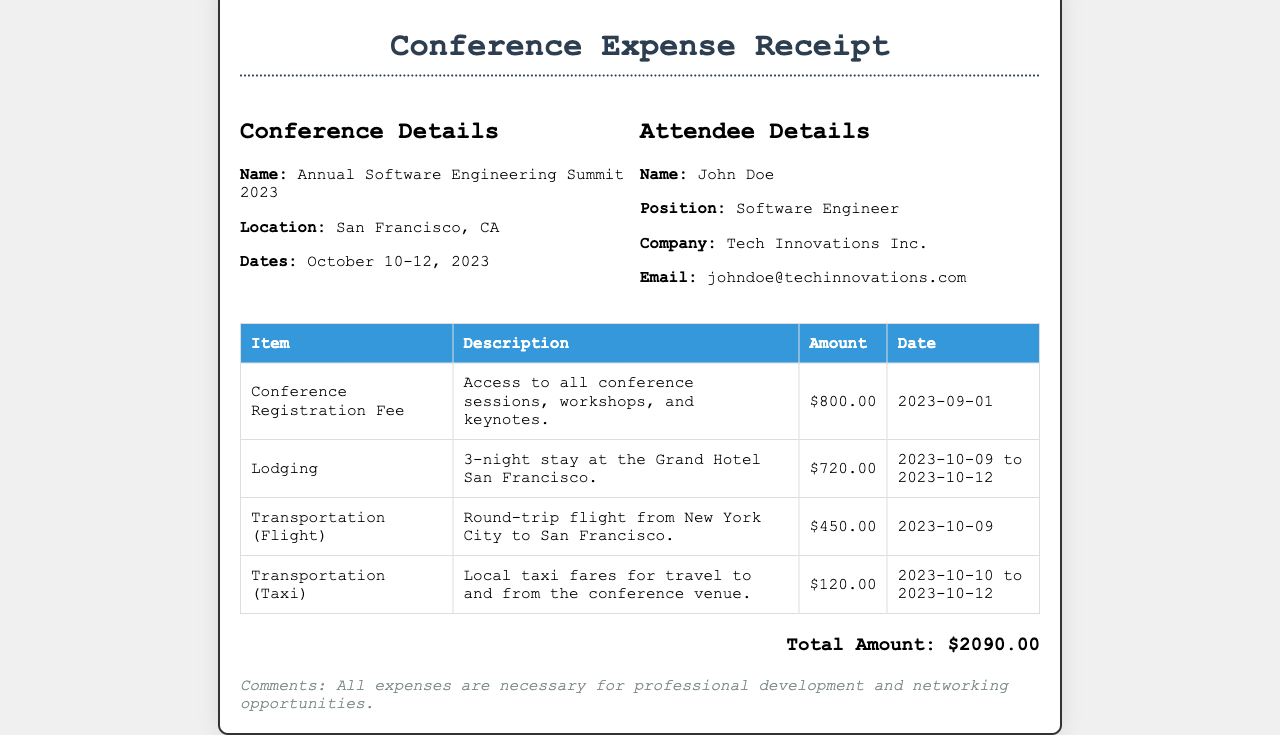What is the name of the conference? The name of the conference is given in the document, which is "Annual Software Engineering Summit 2023."
Answer: Annual Software Engineering Summit 2023 What is the total amount of the expenses? The total amount represents the sum of all listed expenses in the document, which sums up to $2090.00.
Answer: $2090.00 How many nights did the lodging cover? The lodging entry specifies a "3-night stay," indicating the duration covered by the expense.
Answer: 3 What is the registration fee amount? The document explicitly lists the registration fee amount, which is $800.00.
Answer: $800.00 What city is the conference held in? The location of the conference is clearly mentioned in the document as "San Francisco, CA."
Answer: San Francisco, CA What transportation type had the highest expense? By comparing the amounts listed for transportation, the flight expense of $450.00 is the highest.
Answer: Flight What company does the attendee work for? The document provides attendee details, specifying the name of the company as "Tech Innovations Inc."
Answer: Tech Innovations Inc How many local taxi fares were included in the expenses? The document lists one entry for "Transportation (Taxi)," indicating there was one fare included.
Answer: One What are the dates of the conference? The document mentions specific dates for the conference, which are "October 10-12, 2023."
Answer: October 10-12, 2023 